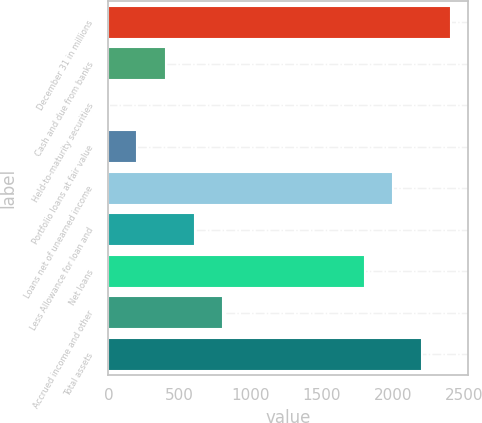Convert chart. <chart><loc_0><loc_0><loc_500><loc_500><bar_chart><fcel>December 31 in millions<fcel>Cash and due from banks<fcel>Held-to-maturity securities<fcel>Portfolio loans at fair value<fcel>Loans net of unearned income<fcel>Less Allowance for loan and<fcel>Net loans<fcel>Accrued income and other<fcel>Total assets<nl><fcel>2404.2<fcel>403.8<fcel>1<fcel>202.4<fcel>2001.4<fcel>605.2<fcel>1800<fcel>806.6<fcel>2202.8<nl></chart> 